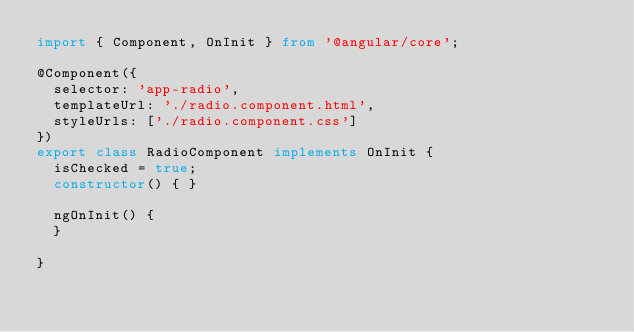Convert code to text. <code><loc_0><loc_0><loc_500><loc_500><_TypeScript_>import { Component, OnInit } from '@angular/core';

@Component({
  selector: 'app-radio',
  templateUrl: './radio.component.html',
  styleUrls: ['./radio.component.css']
})
export class RadioComponent implements OnInit {
  isChecked = true;
  constructor() { }

  ngOnInit() {
  }

}
</code> 